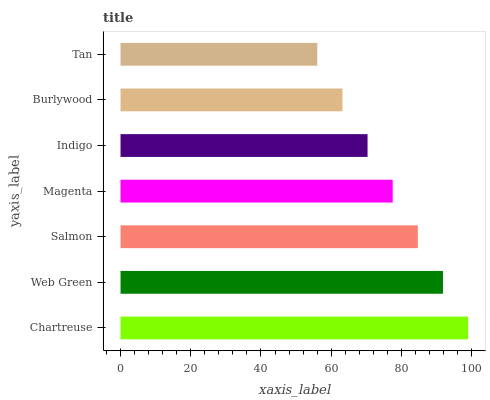Is Tan the minimum?
Answer yes or no. Yes. Is Chartreuse the maximum?
Answer yes or no. Yes. Is Web Green the minimum?
Answer yes or no. No. Is Web Green the maximum?
Answer yes or no. No. Is Chartreuse greater than Web Green?
Answer yes or no. Yes. Is Web Green less than Chartreuse?
Answer yes or no. Yes. Is Web Green greater than Chartreuse?
Answer yes or no. No. Is Chartreuse less than Web Green?
Answer yes or no. No. Is Magenta the high median?
Answer yes or no. Yes. Is Magenta the low median?
Answer yes or no. Yes. Is Chartreuse the high median?
Answer yes or no. No. Is Burlywood the low median?
Answer yes or no. No. 